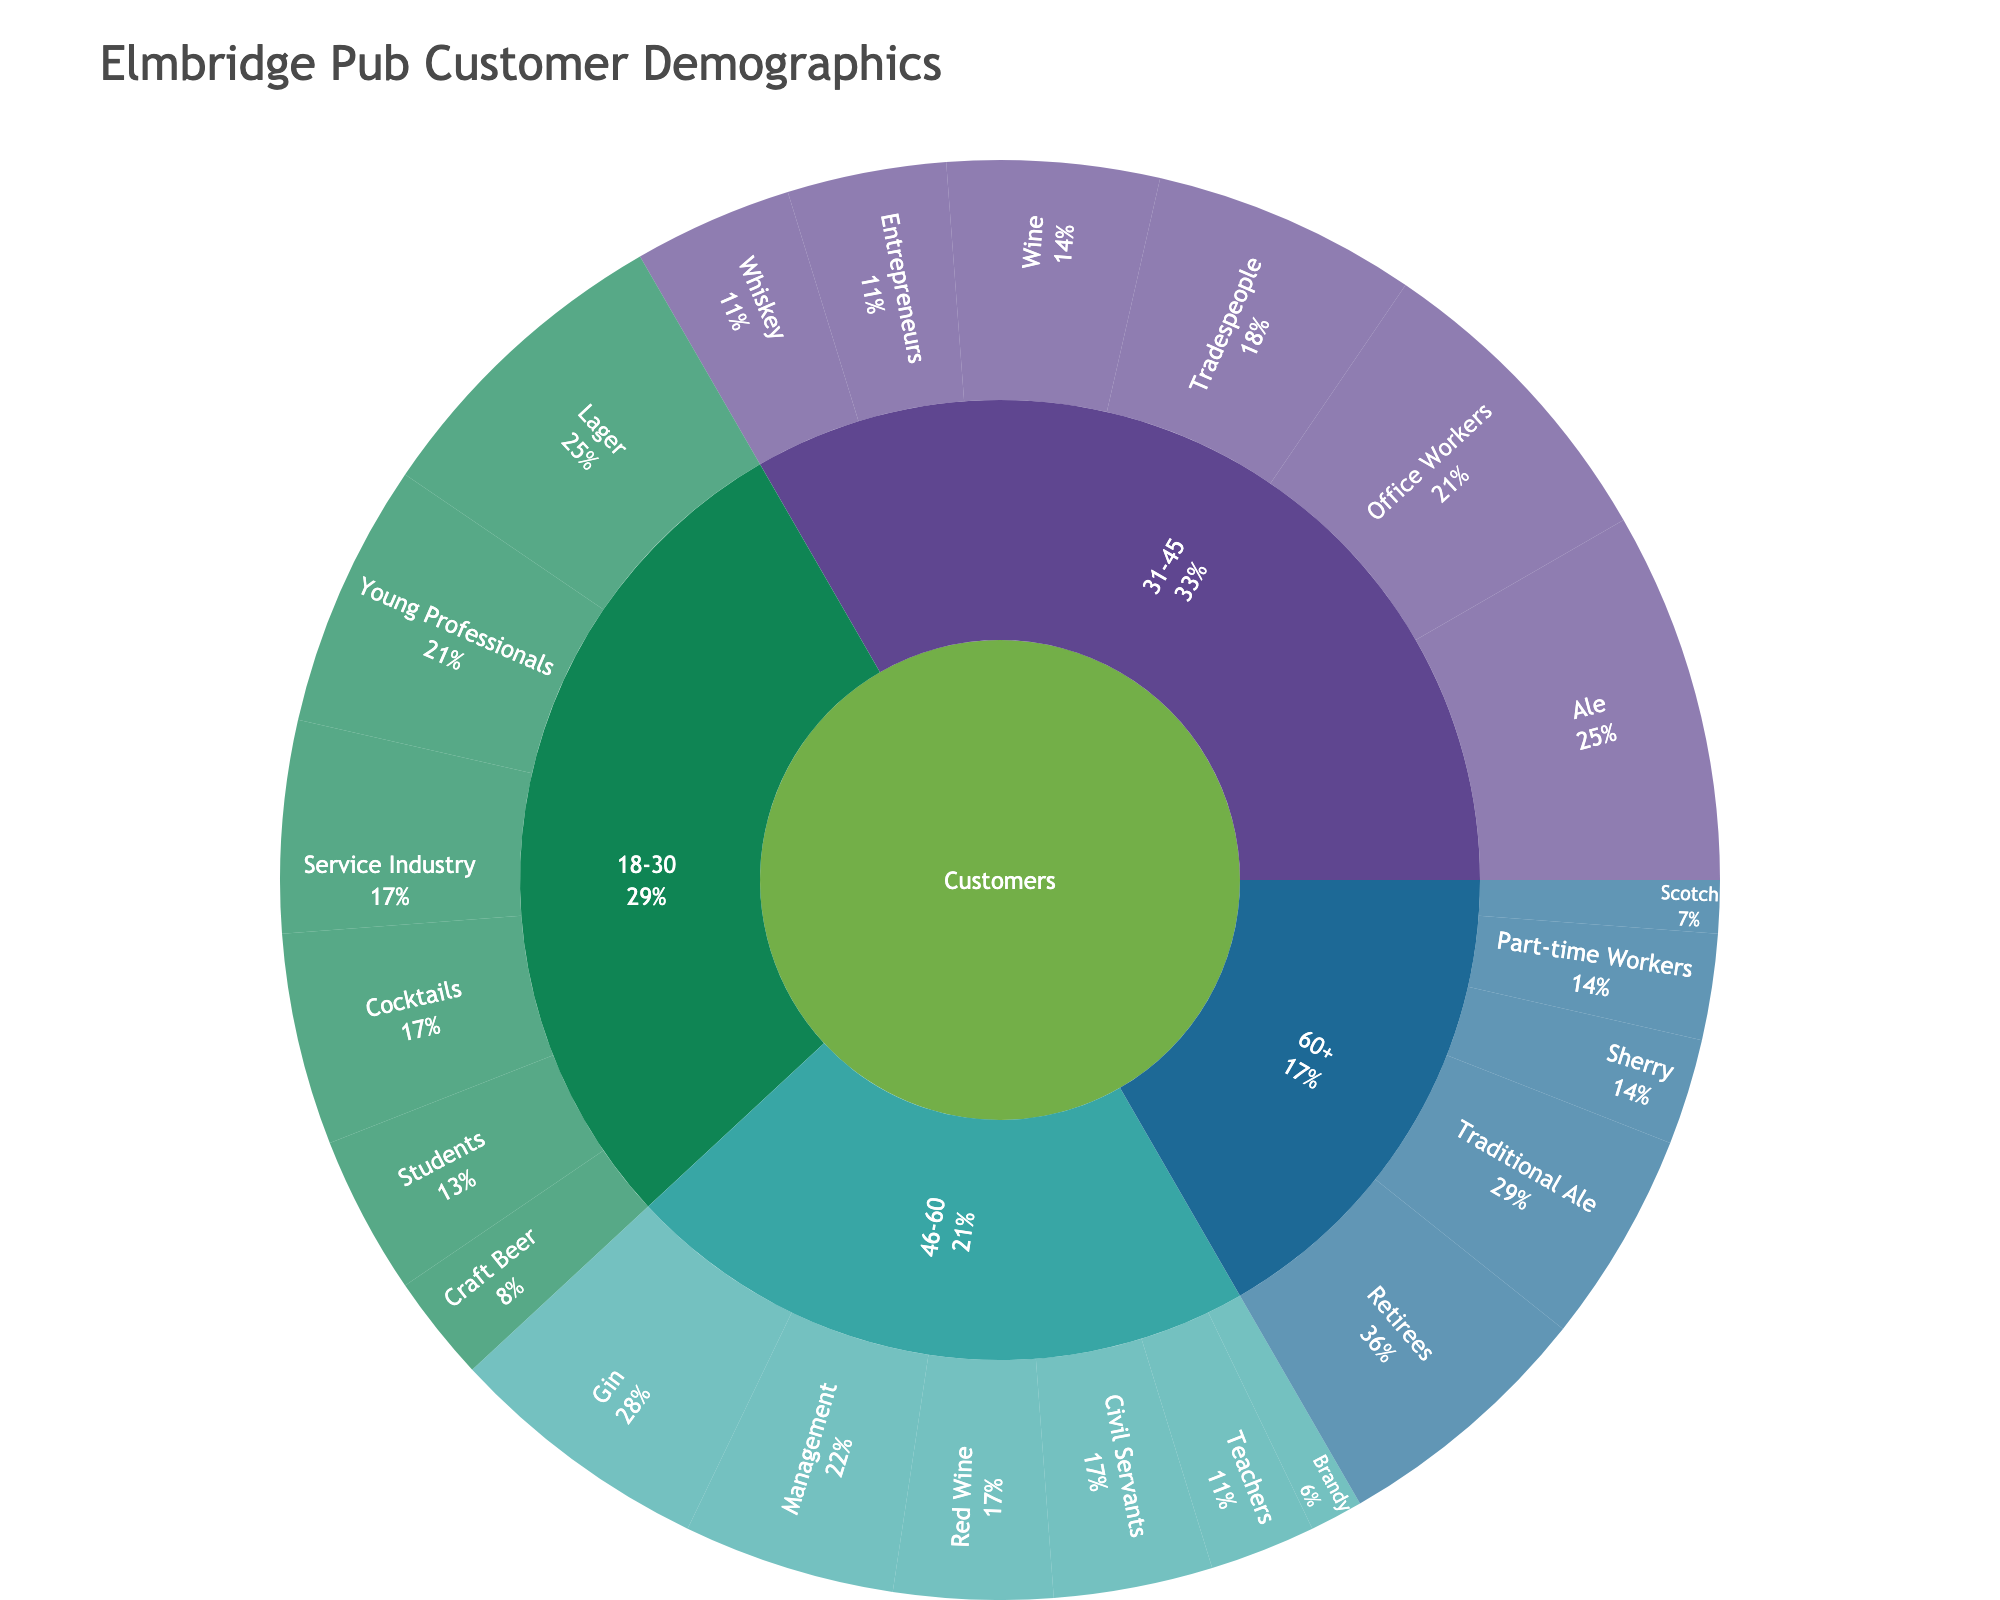What is the most popular age group among the pub's customers? By observing the segments of the sunburst plot, the '31-45' age group has the largest total value, indicated by the more expansive segments.
Answer: 31-45 Which profession has the highest representation in the pub among the 31-45 age group? By focusing on the '31-45' category and its subcategories, 'Office Workers' have the largest segment within this age group.
Answer: Office Workers How many customers are there in the '18-30' age group preferring Lager? The sunburst plot shows a segment for 'Lager' under the '18-30' category. The value for this segment is '30'.
Answer: 30 How many total customers are in the '46-60' age group? Adding the values for all subcategories under the '46-60' category: 20 (Management) + 15 (Civil Servants) + 10 (Teachers) = 45.
Answer: 45 Which drinking preference is more popular in the 60+ age group, Sherry or Scotch? Comparing the 'Sherry' and 'Scotch' segments in the '60+' age group: 'Sherry' has a value of 10, while 'Scotch' has a value of 5.
Answer: Sherry Which age group has a higher number of students? Observing the segments under 'Students' in the age categories: '18-30' has 15 students, while other age groups do not specify students.
Answer: 18-30 What is the total number of Young Professionals in the pub? The 'Young Professionals' are present in the '18-30' age group. The segment shows a value of 25.
Answer: 25 Compare the total number of customers who prefer cocktails to those who prefer wine. Observing relevant segments: Cocktails (20) in '18-30' and Wine (20) in '31-45'. Sum of preferences: 20 (Cocktails) vs 20 (Wine).
Answer: Equal What is the proportion of tradespeople within the 31-45 age group? Tradespeople have a value of 25 within the '31-45' age group, which has a total of 70 (sum of 30+25+15). Calculating the proportion: 25/70 = 35.7%.
Answer: 35.7% Which age group has the least number of people preferring Ale or Traditional Ale? Observing Ale/Traditional Ale preferences: '31-45' has 35 for Ale, '60+' has 20 for Traditional Ale. Out of these, '60+' is the lesser value.
Answer: 60+ 